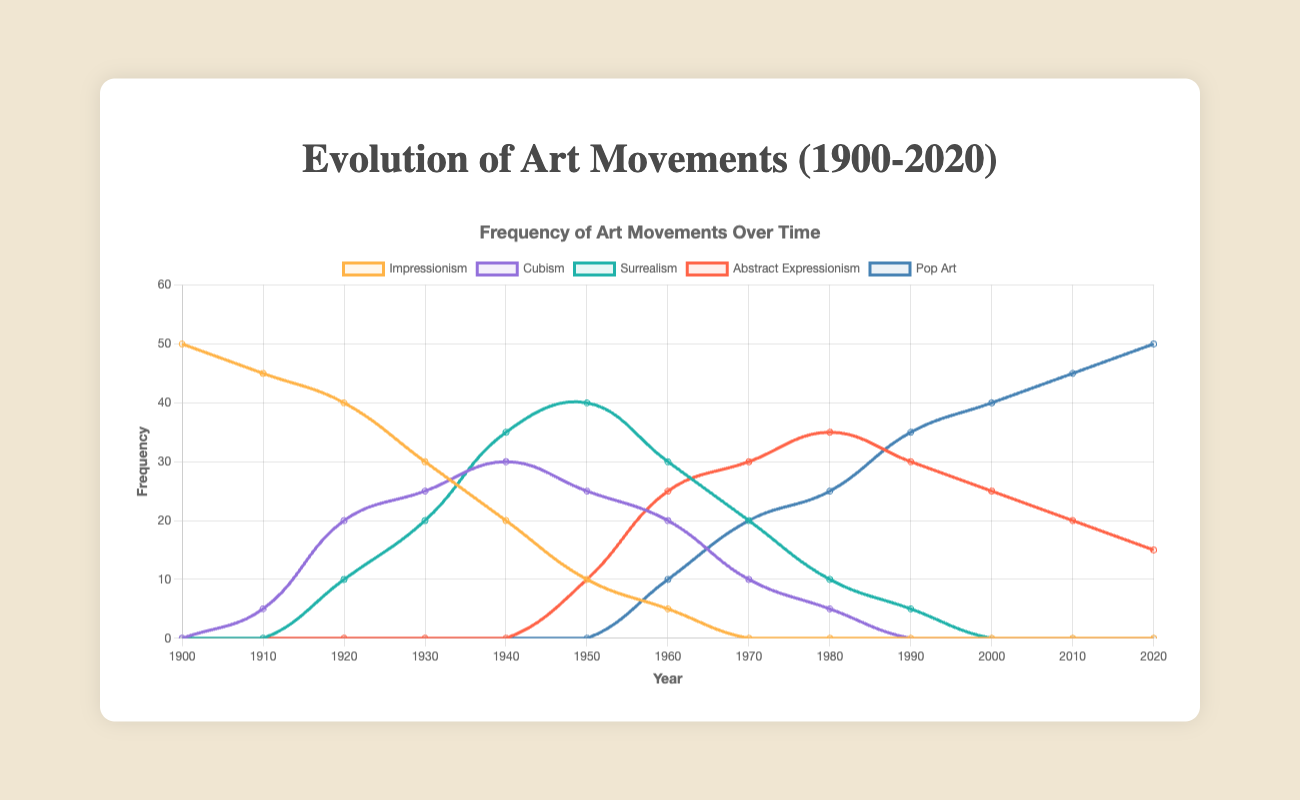What is the peak frequency of Surrealism, and in which decade did it occur? To find the peak frequency of Surrealism, look at its highest point on the line plot. The highest frequency for Surrealism is 40, which occurs in the 1950s.
Answer: 1950s Which art movement had the highest frequency in 1960? Compare the heights of the lines at the year 1960. The art movement with the highest frequency in 1960 is Surrealism with a frequency of 30.
Answer: Surrealism Between 1940 and 1960, which art movements increased in frequency, and which decreased? We need to observe the trends in the plot between the years 1940 and 1960: Impressionism decreased from 20 to 5, Cubism decreased from 30 to 20, Surrealism decreased from 35 to 30, Abstract Expressionism increased from 0 to 25, and Pop Art increased from 0 to 10.
Answer: Abstract Expressionism, Pop Art increased; Impressionism, Cubism, Surrealism decreased From 1900 to 2020, which art movement maintained a non-zero frequency the longest? Evaluate which art movement has non-zero values for most years on the plot. Impressionism maintained a non-zero frequency from 1900 to 1960, approximately 60 years.
Answer: Impressionism What is the combined frequency of Cubism and Pop Art in the year 2000? Look at the frequencies of Cubism and Pop Art at the year 2000. Cubism has a frequency of 0, and Pop Art has a frequency of 40. The combined frequency is 0 + 40 = 40.
Answer: 40 In which decade did Abstract Expressionism first surpass Surrealism in frequency? Examine the crossover point between the lines representing Abstract Expressionism and Surrealism. Abstract Expressionism first surpasses Surrealism in the 1970s.
Answer: 1970s What is the trend in the frequency of Impressionism from 1900 to 1930? Observe the line for Impressionism from 1900 to 1930. The frequency of Impressionism decreases steadily from 50 to 30 over these years.
Answer: Decreasing How does the frequency of Surrealism in 1950 compare to that of Pop Art in 2020? Look at the frequencies of Surrealism in 1950 and Pop Art in 2020. Both have a frequency of 40.
Answer: Equal During which decade did Cubism reach its peak, and what was its frequency? Find the highest point in the Cubism line on the plot. Cubism reached its peak frequency of 30 in the 1940s.
Answer: 1940s, 30 What is the difference in frequency between Abstract Expressionism and Pop Art in 2010? Check the frequencies of both art movements in 2010. Abstract Expressionism has a frequency of 20 and Pop Art has 45. The difference is 45 - 20 = 25.
Answer: 25 